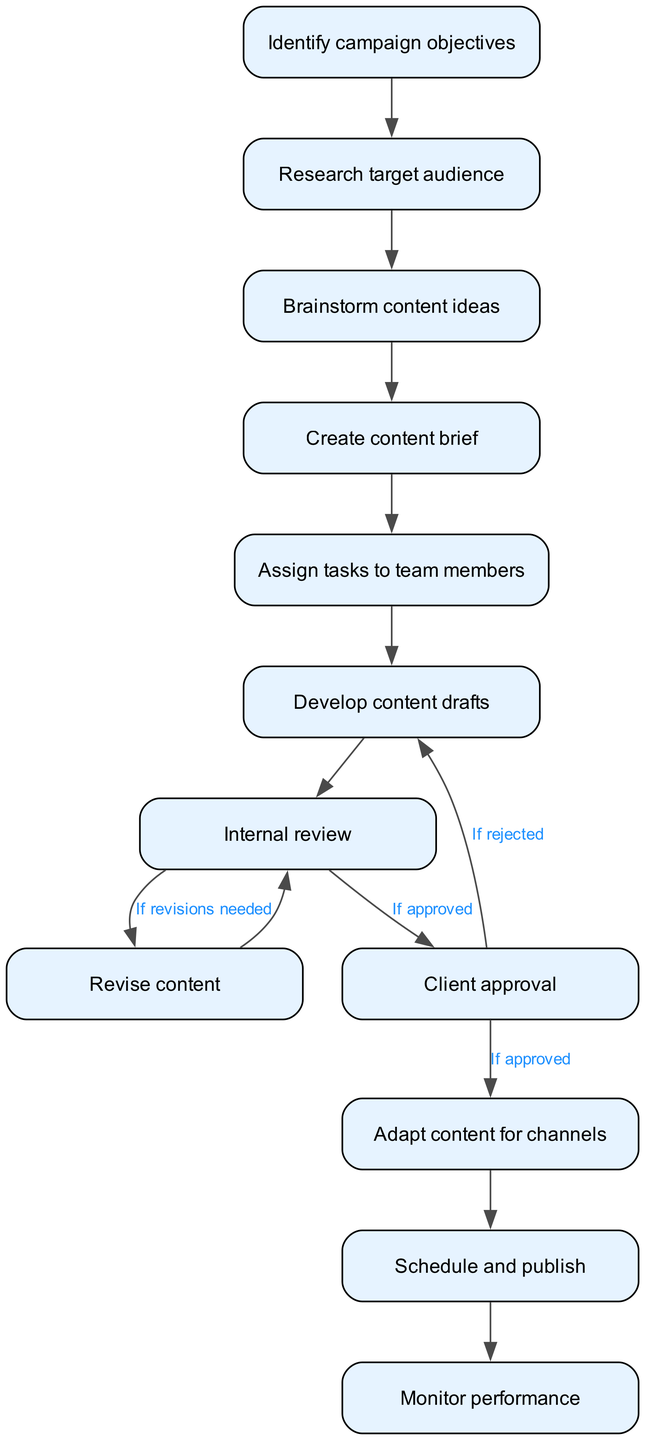What is the first step in the workflow? The first step in the workflow is represented by the node labeled "Identify campaign objectives," which initiates the process.
Answer: Identify campaign objectives How many nodes are present in the diagram? By counting the nodes listed in the provided data, there are a total of twelve nodes that represent different steps in the workflow.
Answer: Twelve What action follows the internal review? After the "Internal review," the next step can either be "Revise content" if revisions are needed, or "Client approval" if the content is approved, but "Client approval" is the immediate option when it is approved.
Answer: Client approval What happens if content is rejected after client approval? If the content is rejected after client approval, the workflow indicates that it goes back to "Develop content drafts" for further revisions, represented by the edge from client approval to develop content drafts.
Answer: Develop content drafts What is the final step in the workflow? The final step in this workflow is "Monitor performance," which is the last node that follows the action of scheduling and publishing the content.
Answer: Monitor performance How many edges are there in the diagram? Counting the connections (edges) specified between the nodes, there are a total of twelve edges that illustrate the relationships and flow in the workflow.
Answer: Twelve What are the actions to take if revisions are needed after the internal review? If revisions are needed after the internal review, the action indicated in the diagram is to go back to "Revise content," followed by returning to "Internal review" for further assessment.
Answer: Revise content What is the relationship between "Revise content" and "Internal review"? The relationship is that if revisions are needed (indicated by a flow from "Internal review"), the process circles back to "Revise content," demonstrating a continuous improvement loop until approval is attained.
Answer: Continuous improvement loop 